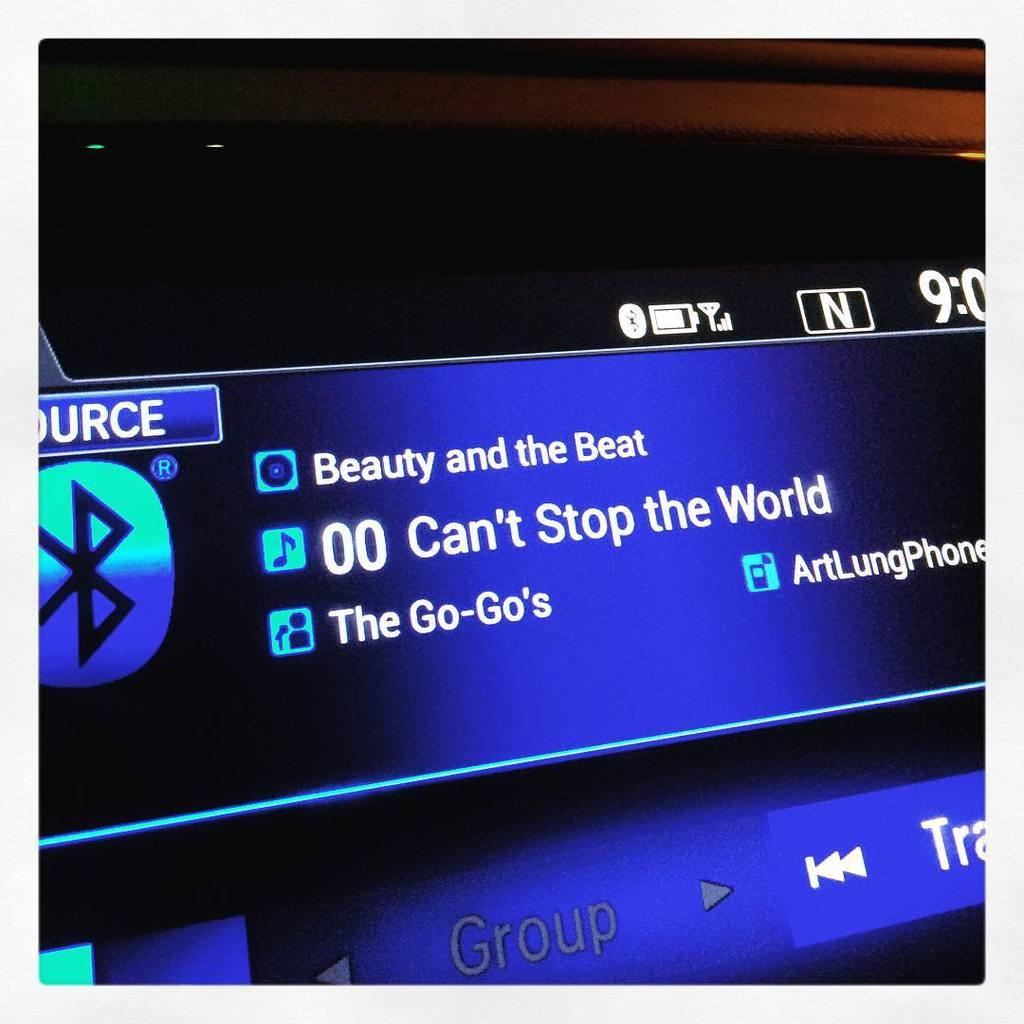<image>
Share a concise interpretation of the image provided. A blue lighted sign has the album from The Go-Go's Beauty and the Beat. 